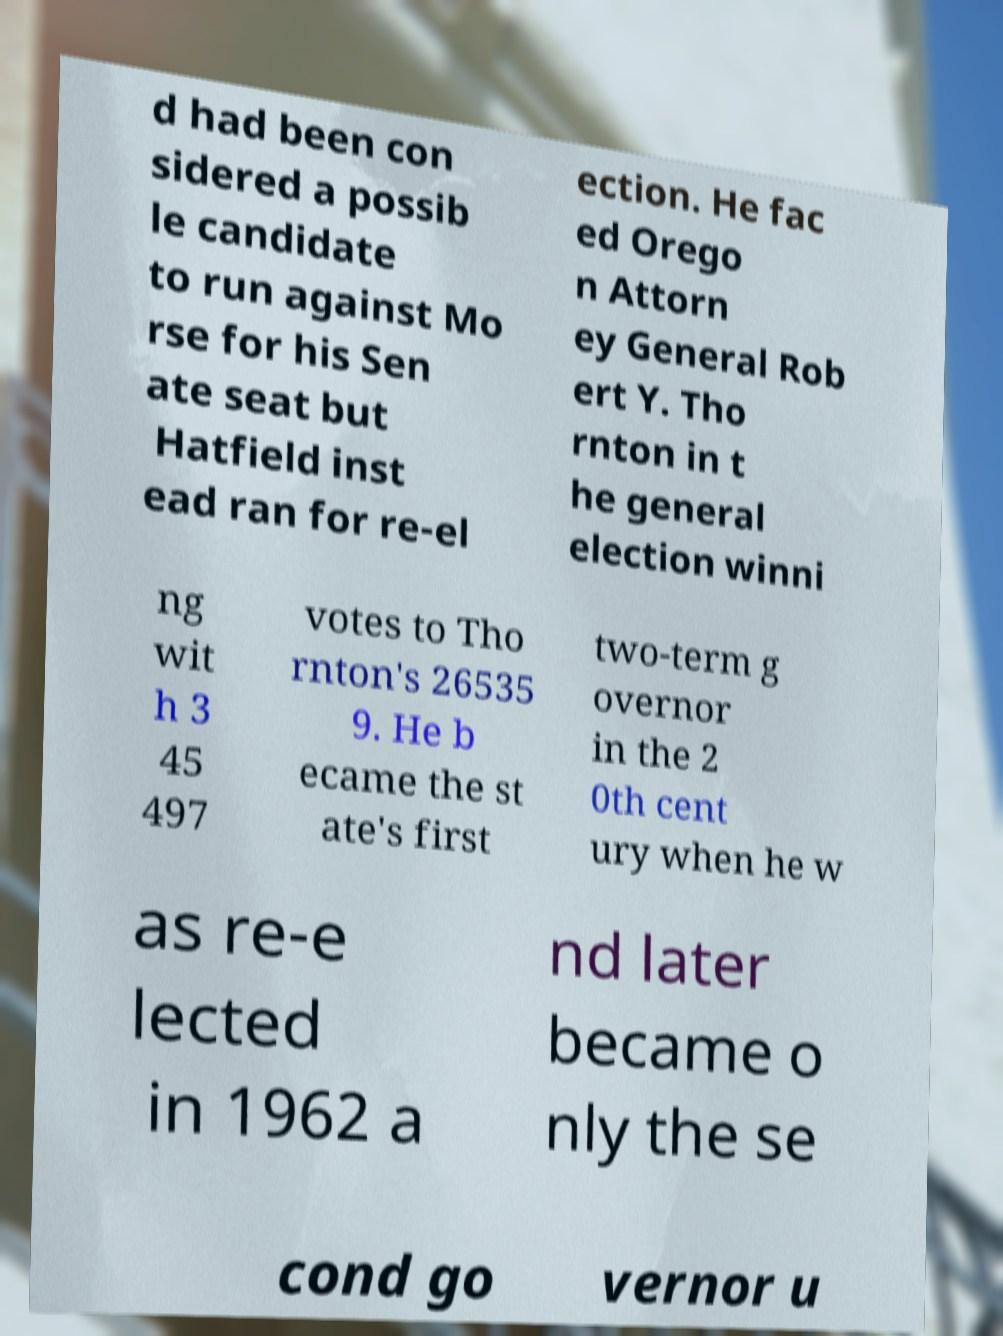Can you accurately transcribe the text from the provided image for me? d had been con sidered a possib le candidate to run against Mo rse for his Sen ate seat but Hatfield inst ead ran for re-el ection. He fac ed Orego n Attorn ey General Rob ert Y. Tho rnton in t he general election winni ng wit h 3 45 497 votes to Tho rnton's 26535 9. He b ecame the st ate's first two-term g overnor in the 2 0th cent ury when he w as re-e lected in 1962 a nd later became o nly the se cond go vernor u 